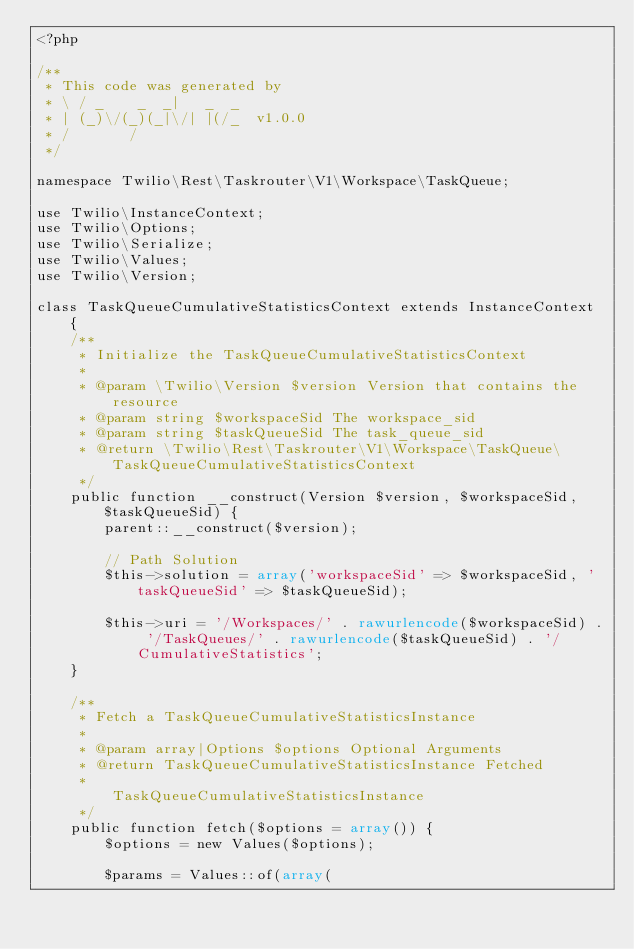<code> <loc_0><loc_0><loc_500><loc_500><_PHP_><?php

/**
 * This code was generated by
 * \ / _    _  _|   _  _
 * | (_)\/(_)(_|\/| |(/_  v1.0.0
 * /       /
 */

namespace Twilio\Rest\Taskrouter\V1\Workspace\TaskQueue;

use Twilio\InstanceContext;
use Twilio\Options;
use Twilio\Serialize;
use Twilio\Values;
use Twilio\Version;

class TaskQueueCumulativeStatisticsContext extends InstanceContext {
    /**
     * Initialize the TaskQueueCumulativeStatisticsContext
     * 
     * @param \Twilio\Version $version Version that contains the resource
     * @param string $workspaceSid The workspace_sid
     * @param string $taskQueueSid The task_queue_sid
     * @return \Twilio\Rest\Taskrouter\V1\Workspace\TaskQueue\TaskQueueCumulativeStatisticsContext 
     */
    public function __construct(Version $version, $workspaceSid, $taskQueueSid) {
        parent::__construct($version);

        // Path Solution
        $this->solution = array('workspaceSid' => $workspaceSid, 'taskQueueSid' => $taskQueueSid);

        $this->uri = '/Workspaces/' . rawurlencode($workspaceSid) . '/TaskQueues/' . rawurlencode($taskQueueSid) . '/CumulativeStatistics';
    }

    /**
     * Fetch a TaskQueueCumulativeStatisticsInstance
     * 
     * @param array|Options $options Optional Arguments
     * @return TaskQueueCumulativeStatisticsInstance Fetched
     *                                               TaskQueueCumulativeStatisticsInstance
     */
    public function fetch($options = array()) {
        $options = new Values($options);

        $params = Values::of(array(</code> 